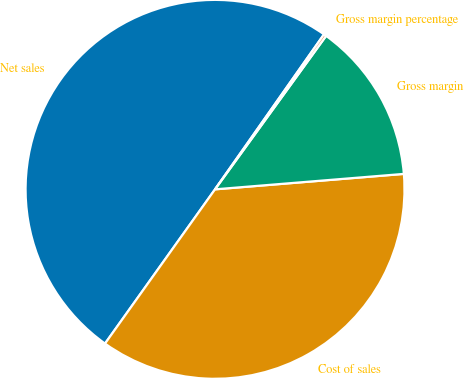<chart> <loc_0><loc_0><loc_500><loc_500><pie_chart><fcel>Net sales<fcel>Cost of sales<fcel>Gross margin<fcel>Gross margin percentage<nl><fcel>49.89%<fcel>36.16%<fcel>13.73%<fcel>0.22%<nl></chart> 